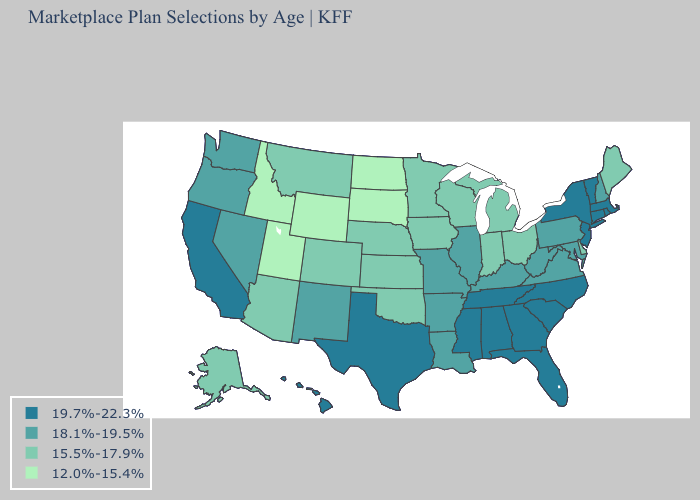Is the legend a continuous bar?
Concise answer only. No. What is the lowest value in the Northeast?
Concise answer only. 15.5%-17.9%. Name the states that have a value in the range 12.0%-15.4%?
Answer briefly. Idaho, North Dakota, South Dakota, Utah, Wyoming. Which states have the lowest value in the Northeast?
Concise answer only. Maine. What is the value of Oklahoma?
Short answer required. 15.5%-17.9%. Does Mississippi have the highest value in the South?
Short answer required. Yes. Name the states that have a value in the range 19.7%-22.3%?
Answer briefly. Alabama, California, Connecticut, Florida, Georgia, Hawaii, Massachusetts, Mississippi, New Jersey, New York, North Carolina, Rhode Island, South Carolina, Tennessee, Texas, Vermont. Among the states that border Maryland , which have the lowest value?
Give a very brief answer. Delaware. Does Ohio have the highest value in the USA?
Keep it brief. No. Name the states that have a value in the range 15.5%-17.9%?
Quick response, please. Alaska, Arizona, Colorado, Delaware, Indiana, Iowa, Kansas, Maine, Michigan, Minnesota, Montana, Nebraska, Ohio, Oklahoma, Wisconsin. What is the value of Pennsylvania?
Give a very brief answer. 18.1%-19.5%. What is the lowest value in the Northeast?
Answer briefly. 15.5%-17.9%. Does Virginia have the highest value in the South?
Quick response, please. No. 